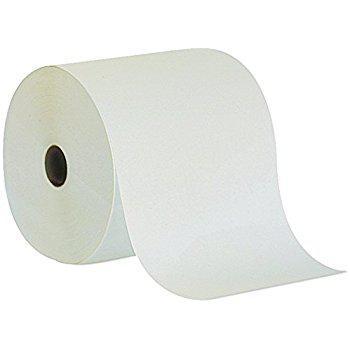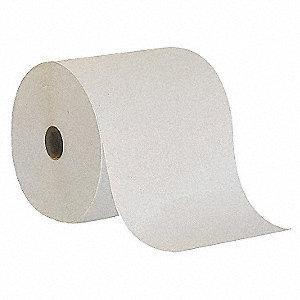The first image is the image on the left, the second image is the image on the right. For the images displayed, is the sentence "The right-hand roll is noticeably browner and darker in color." factually correct? Answer yes or no. Yes. 